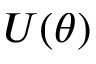<formula> <loc_0><loc_0><loc_500><loc_500>U ( \theta )</formula> 